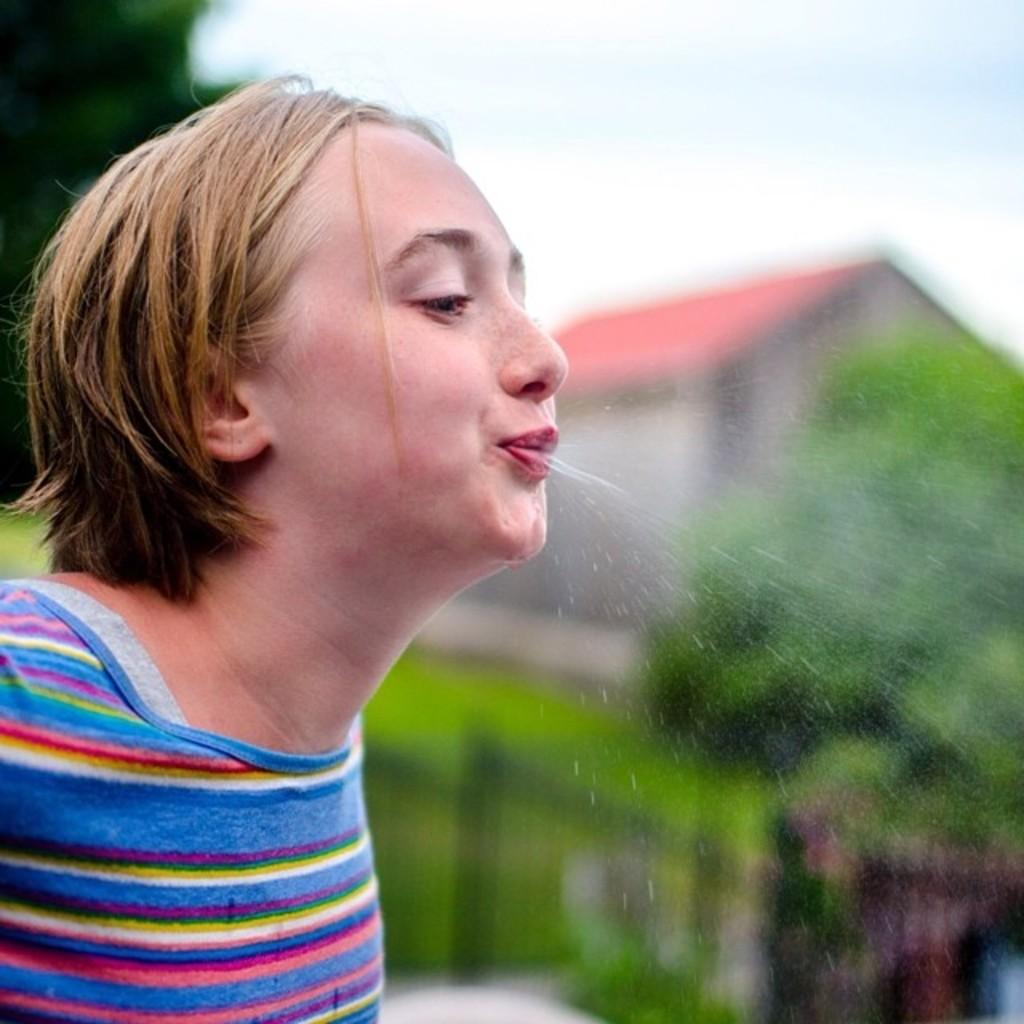What is the main subject of the image? There is a person in the image. What is the person doing in the image? The person is spitting water. What type of natural environment can be seen in the image? There are trees in the image. What type of structure is present in the image? There is a house in the image. What is visible in the background of the image? The sky is visible in the image. How would you describe the background of the image? The background of the image is blurred. What type of lace is being used to create the person's reaction in the image? There is no lace present in the image, nor is there any indication of a reaction being created by lace. 